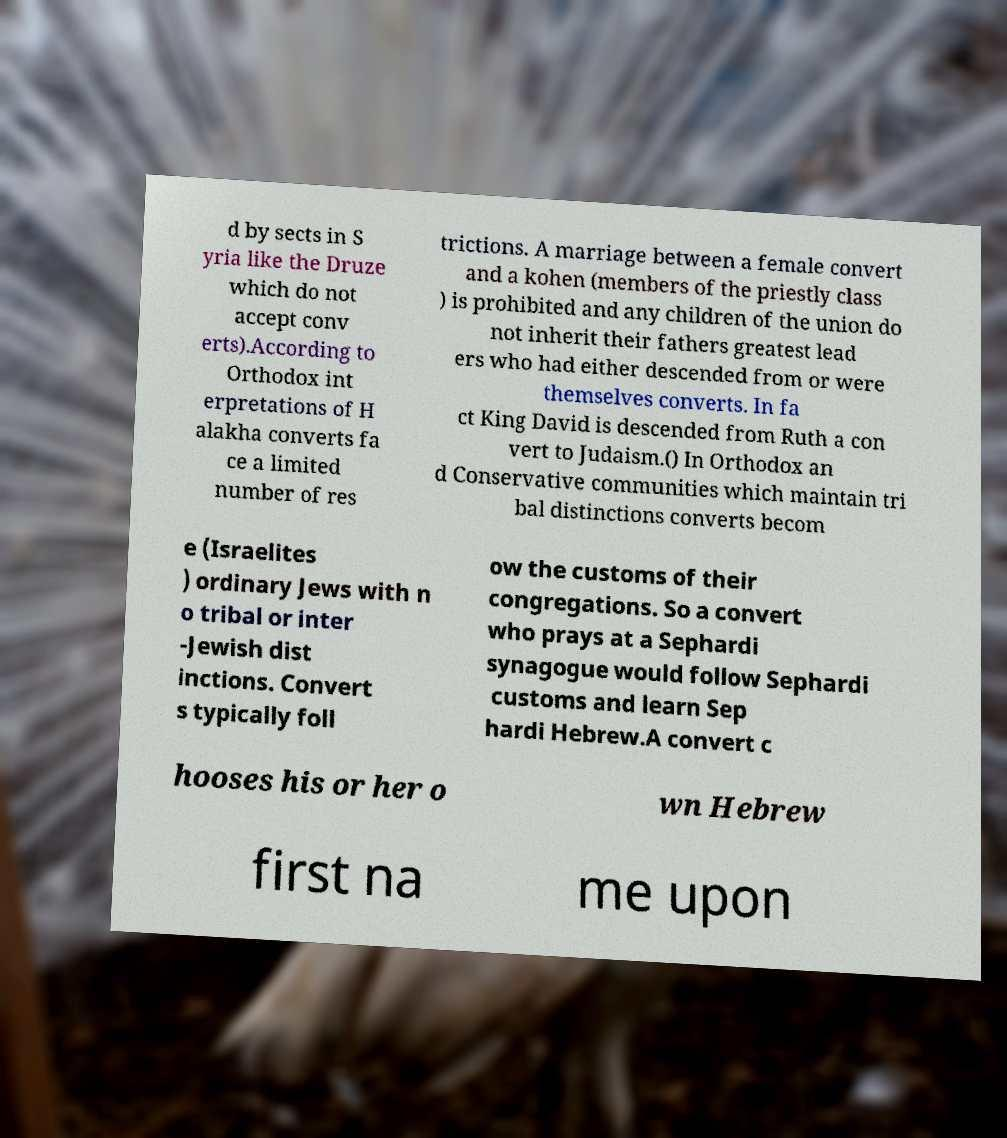For documentation purposes, I need the text within this image transcribed. Could you provide that? d by sects in S yria like the Druze which do not accept conv erts).According to Orthodox int erpretations of H alakha converts fa ce a limited number of res trictions. A marriage between a female convert and a kohen (members of the priestly class ) is prohibited and any children of the union do not inherit their fathers greatest lead ers who had either descended from or were themselves converts. In fa ct King David is descended from Ruth a con vert to Judaism.() In Orthodox an d Conservative communities which maintain tri bal distinctions converts becom e (Israelites ) ordinary Jews with n o tribal or inter -Jewish dist inctions. Convert s typically foll ow the customs of their congregations. So a convert who prays at a Sephardi synagogue would follow Sephardi customs and learn Sep hardi Hebrew.A convert c hooses his or her o wn Hebrew first na me upon 